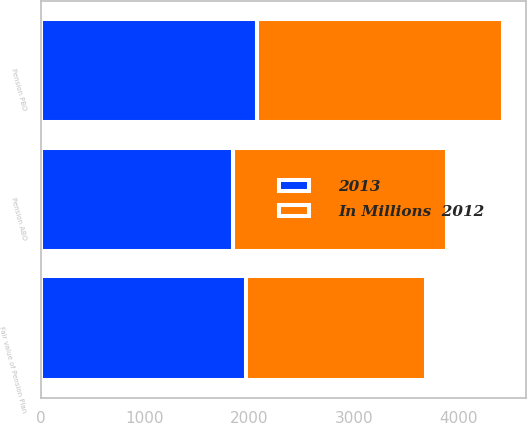Convert chart. <chart><loc_0><loc_0><loc_500><loc_500><stacked_bar_chart><ecel><fcel>Pension PBO<fcel>Pension ABO<fcel>Fair value of Pension Plan<nl><fcel>2013<fcel>2073<fcel>1843<fcel>1964<nl><fcel>In Millions  2012<fcel>2354<fcel>2054<fcel>1727<nl></chart> 